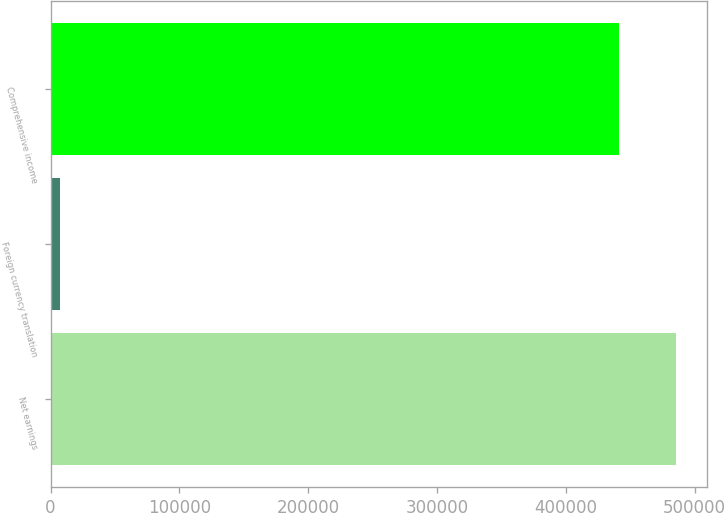Convert chart. <chart><loc_0><loc_0><loc_500><loc_500><bar_chart><fcel>Net earnings<fcel>Foreign currency translation<fcel>Comprehensive income<nl><fcel>485508<fcel>7354<fcel>441380<nl></chart> 